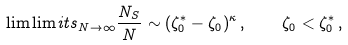<formula> <loc_0><loc_0><loc_500><loc_500>\lim \lim i t s _ { N \to \infty } \frac { N _ { S } } { N } \sim ( \zeta _ { 0 } ^ { * } - \zeta _ { 0 } ) ^ { \kappa } \, , \quad \zeta _ { 0 } < \zeta _ { 0 } ^ { * } \, ,</formula> 